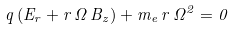<formula> <loc_0><loc_0><loc_500><loc_500>q \, ( E _ { r } + r \, \Omega \, B _ { z } ) + m _ { e } \, r \, \Omega ^ { 2 } = 0</formula> 